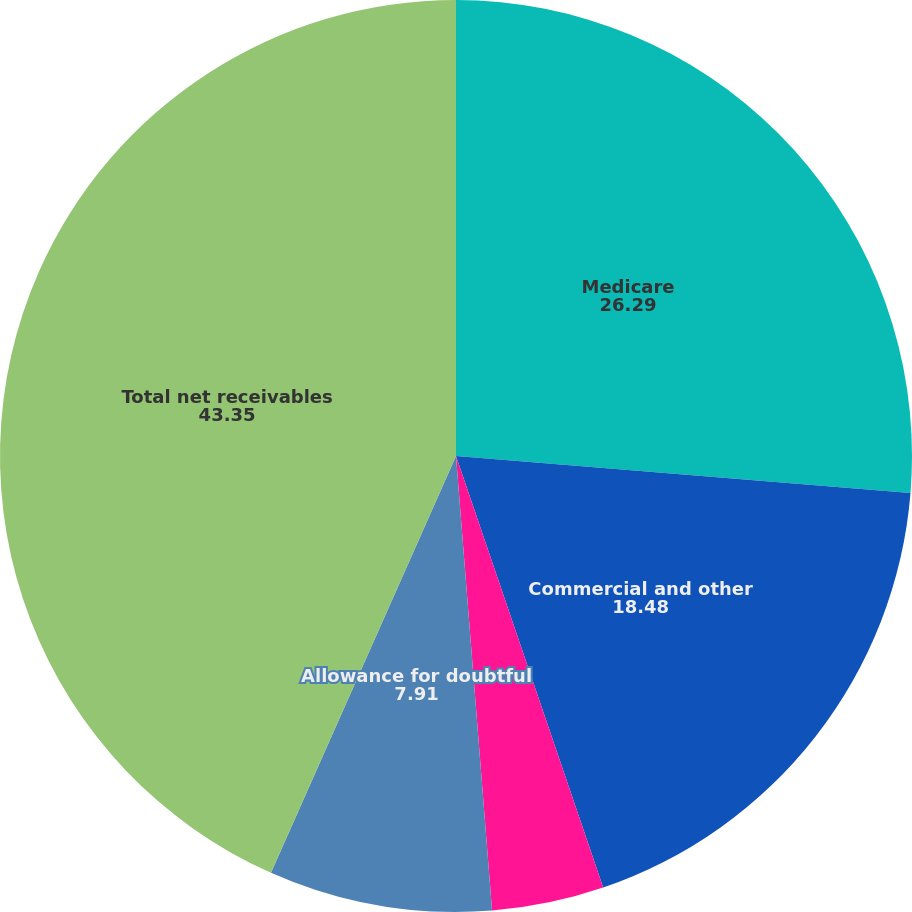Convert chart to OTSL. <chart><loc_0><loc_0><loc_500><loc_500><pie_chart><fcel>Medicare<fcel>Commercial and other<fcel>Military services<fcel>Allowance for doubtful<fcel>Total net receivables<nl><fcel>26.29%<fcel>18.48%<fcel>3.97%<fcel>7.91%<fcel>43.35%<nl></chart> 